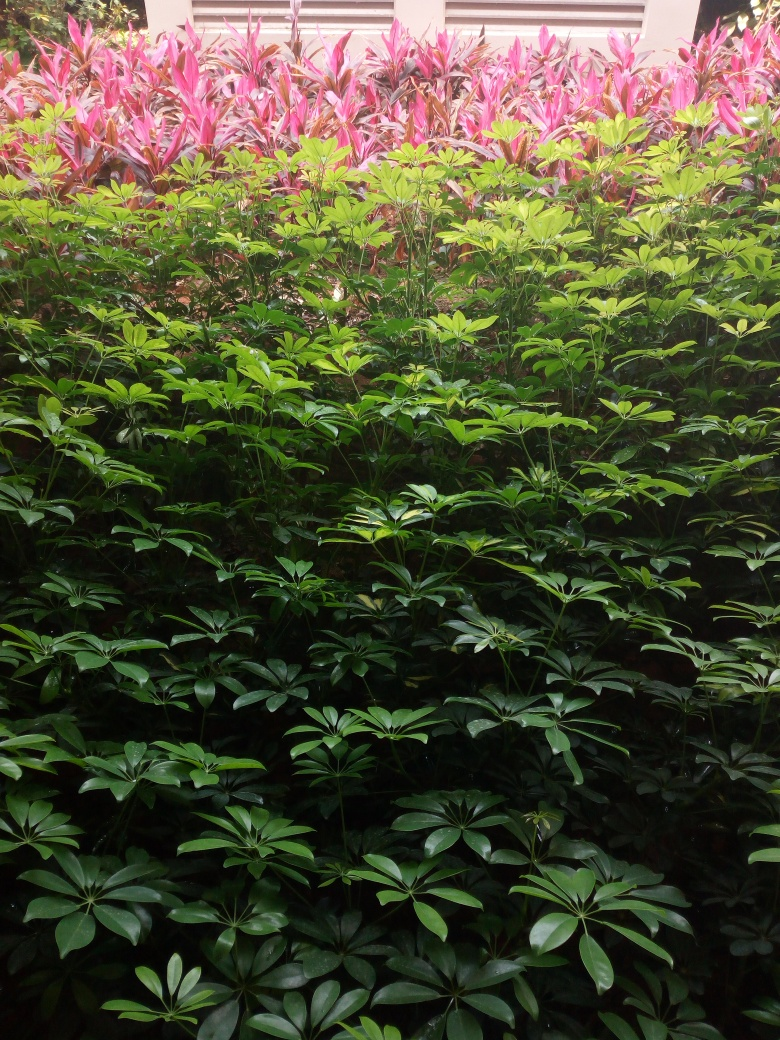Could this environment be considered suitable for all the plant species observed? From the lushness and health of the foliage visible, it seems that the environment is indeed suitable for these plants. The greenery indicates that they are receiving adequate light and moisture. The presence of multiple layers of plants with varying leaf colors and sizes suggests a well-balanced habitat that caters to their growth requirements. 